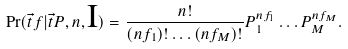<formula> <loc_0><loc_0><loc_500><loc_500>\Pr ( \vec { t } { f } | \vec { t } { P } , n , \text {I} ) = \frac { n ! } { ( n f _ { 1 } ) ! \dots ( n f _ { M } ) ! } P _ { 1 } ^ { n f _ { 1 } } \dots P _ { M } ^ { n f _ { M } } .</formula> 